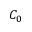<formula> <loc_0><loc_0><loc_500><loc_500>C _ { 0 }</formula> 